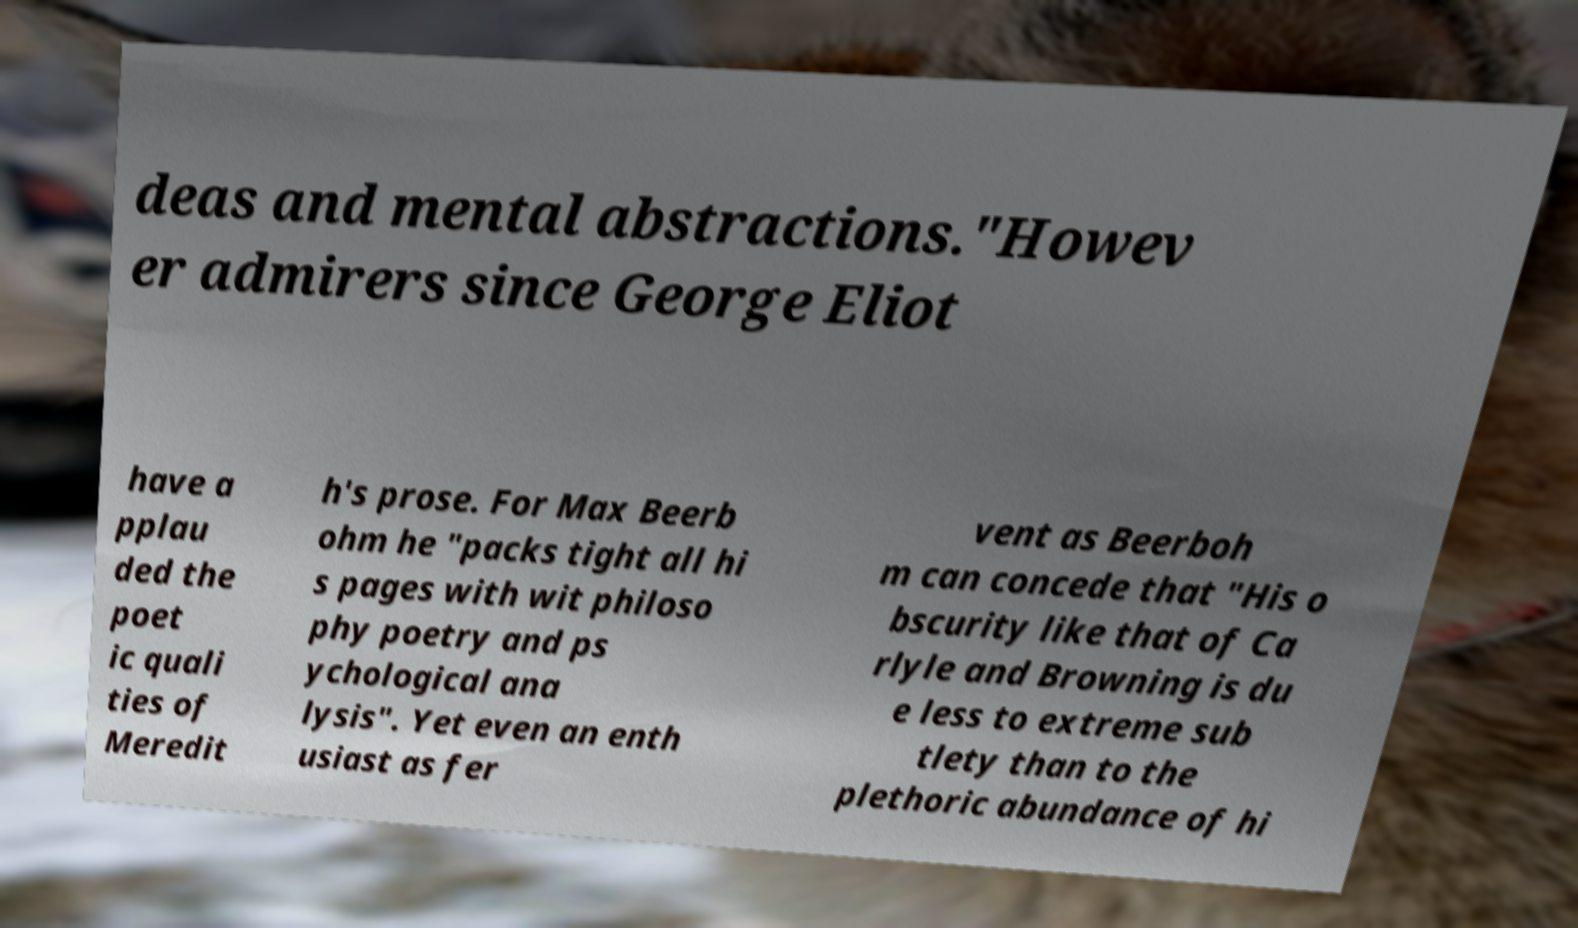Please read and relay the text visible in this image. What does it say? deas and mental abstractions."Howev er admirers since George Eliot have a pplau ded the poet ic quali ties of Meredit h's prose. For Max Beerb ohm he "packs tight all hi s pages with wit philoso phy poetry and ps ychological ana lysis". Yet even an enth usiast as fer vent as Beerboh m can concede that "His o bscurity like that of Ca rlyle and Browning is du e less to extreme sub tlety than to the plethoric abundance of hi 